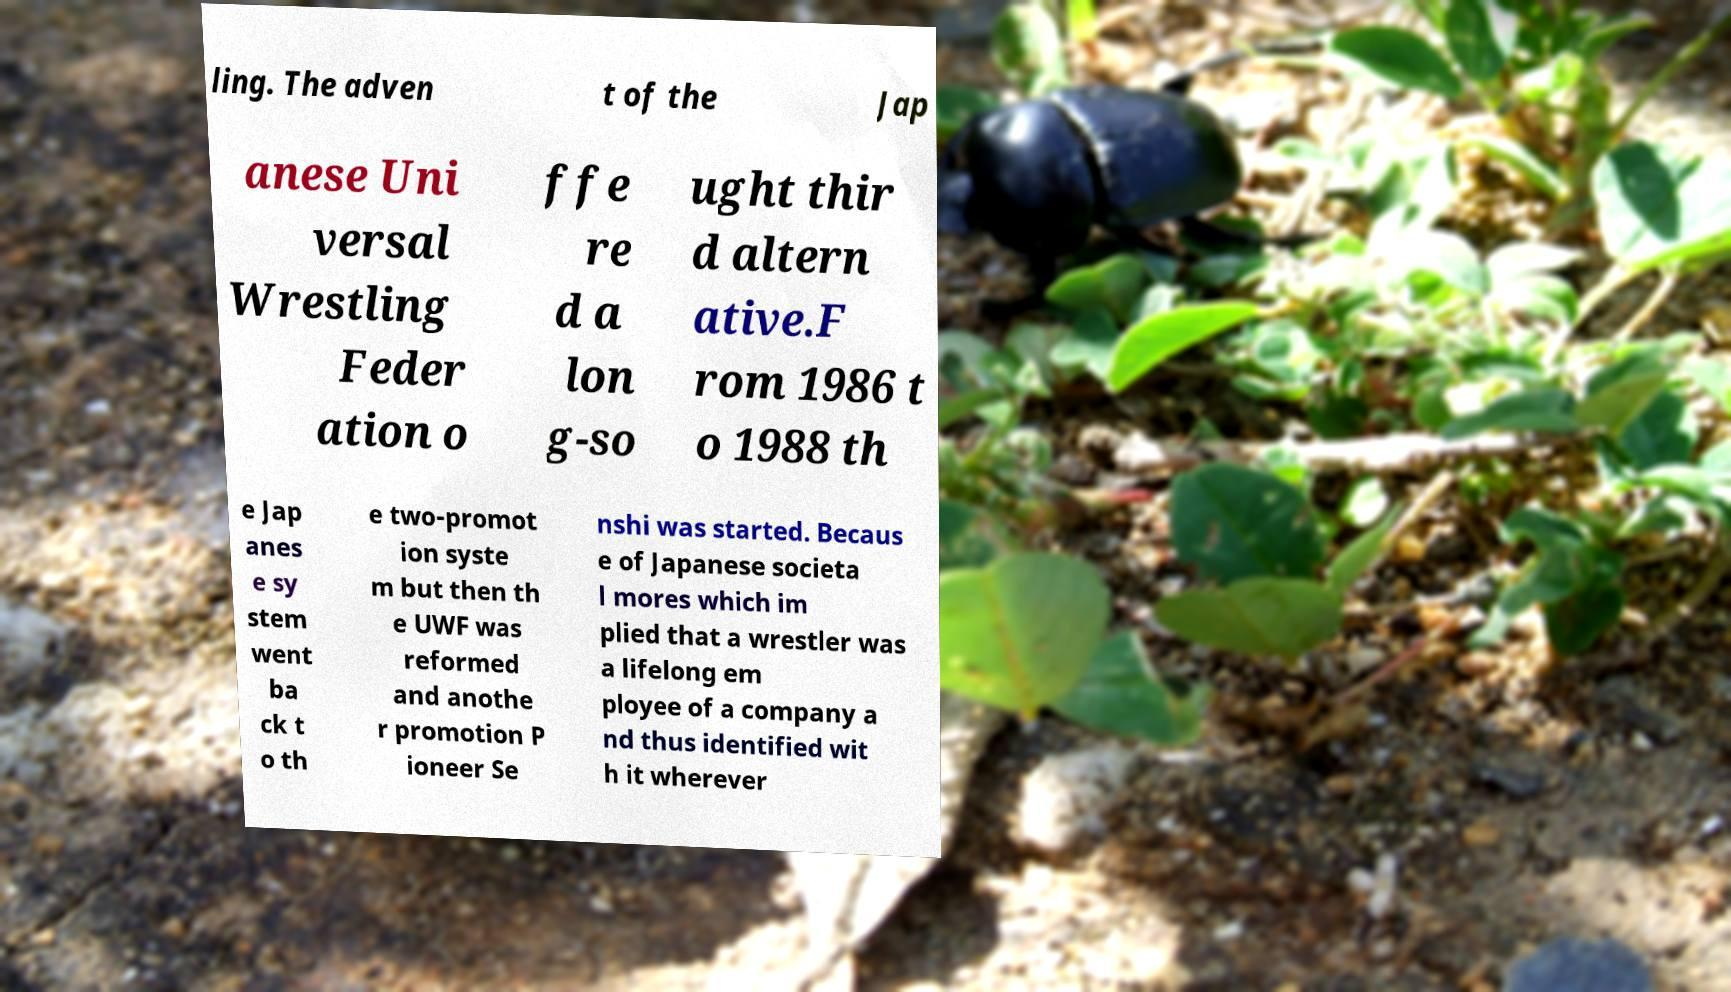What messages or text are displayed in this image? I need them in a readable, typed format. ling. The adven t of the Jap anese Uni versal Wrestling Feder ation o ffe re d a lon g-so ught thir d altern ative.F rom 1986 t o 1988 th e Jap anes e sy stem went ba ck t o th e two-promot ion syste m but then th e UWF was reformed and anothe r promotion P ioneer Se nshi was started. Becaus e of Japanese societa l mores which im plied that a wrestler was a lifelong em ployee of a company a nd thus identified wit h it wherever 